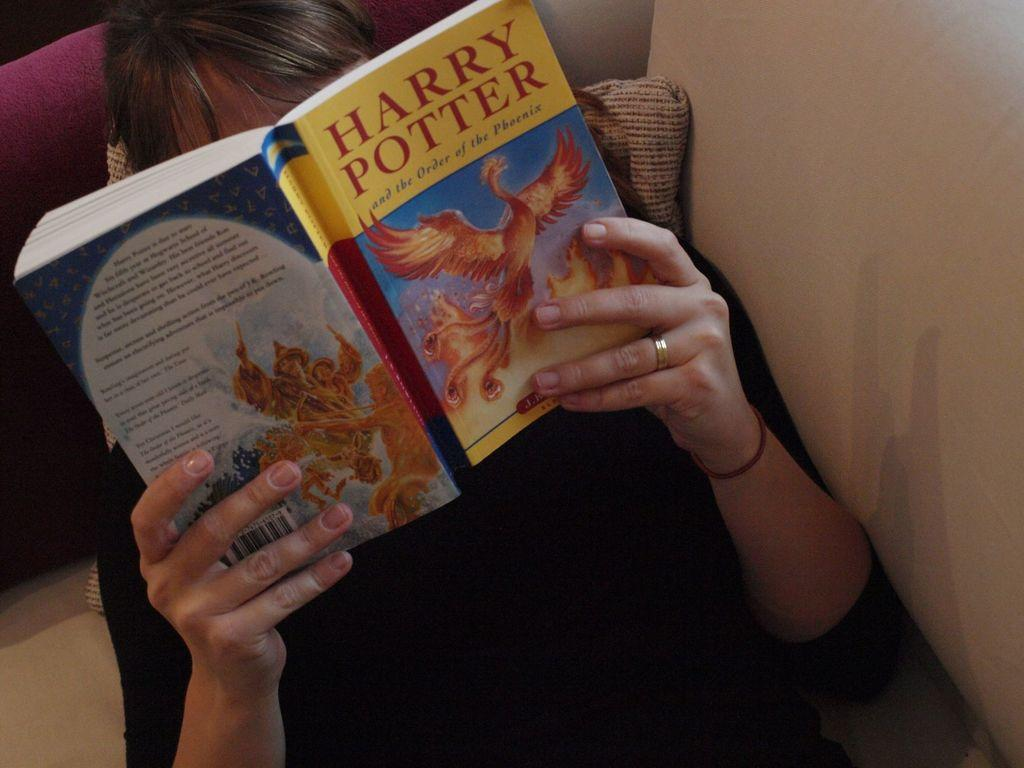<image>
Render a clear and concise summary of the photo. A person laying on a sofa and reading a paperback version of "Harry Potter and the Order of the Phoenix". 